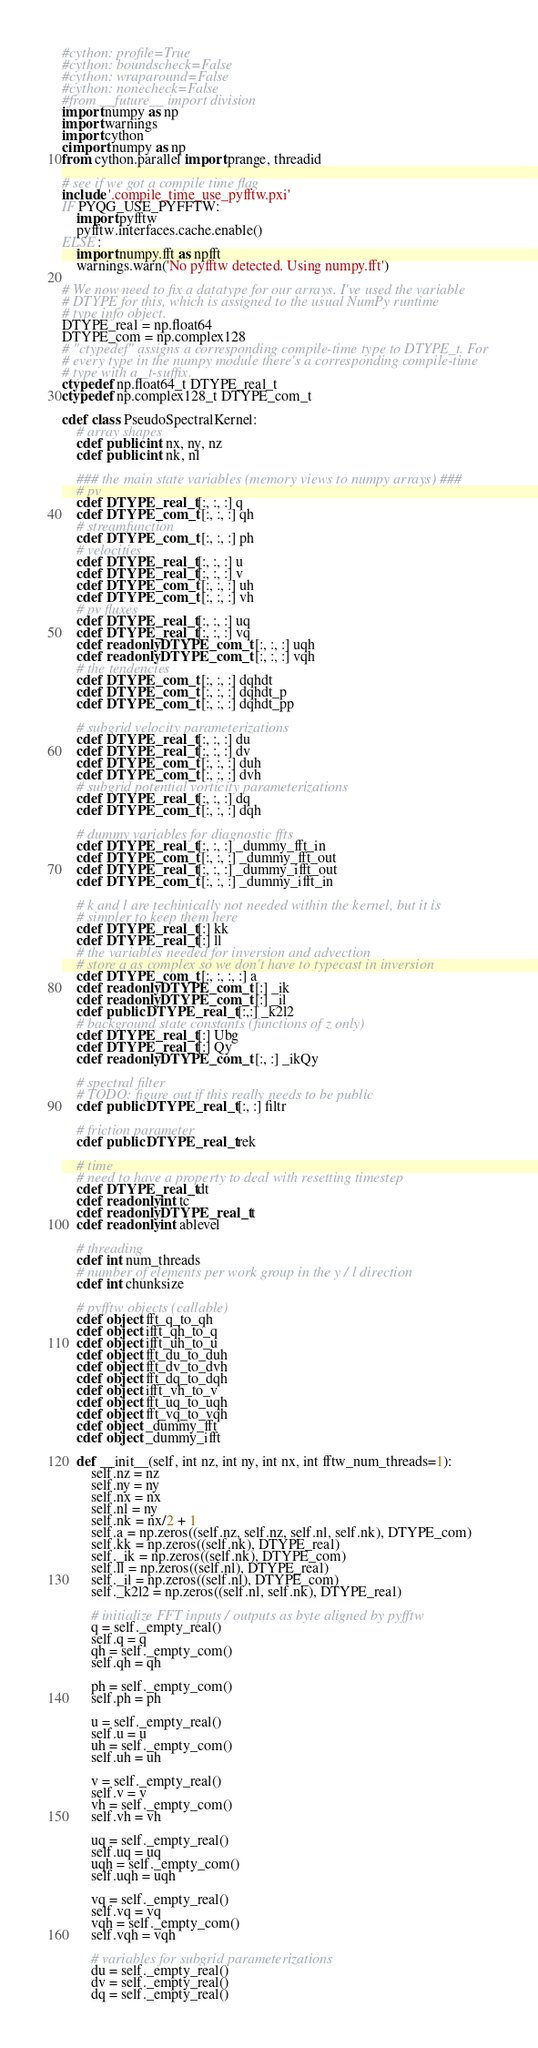<code> <loc_0><loc_0><loc_500><loc_500><_Cython_>#cython: profile=True
#cython: boundscheck=False
#cython: wraparound=False
#cython: nonecheck=False
#from __future__ import division
import numpy as np
import warnings
import cython
cimport numpy as np
from cython.parallel import prange, threadid

# see if we got a compile time flag
include '.compile_time_use_pyfftw.pxi'
IF PYQG_USE_PYFFTW:
    import pyfftw
    pyfftw.interfaces.cache.enable()
ELSE:
    import numpy.fft as npfft
    warnings.warn('No pyfftw detected. Using numpy.fft')

# We now need to fix a datatype for our arrays. I've used the variable
# DTYPE for this, which is assigned to the usual NumPy runtime
# type info object.
DTYPE_real = np.float64
DTYPE_com = np.complex128
# "ctypedef" assigns a corresponding compile-time type to DTYPE_t. For
# every type in the numpy module there's a corresponding compile-time
# type with a _t-suffix.
ctypedef np.float64_t DTYPE_real_t
ctypedef np.complex128_t DTYPE_com_t

cdef class PseudoSpectralKernel:
    # array shapes
    cdef public int nx, ny, nz
    cdef public int nk, nl

    ### the main state variables (memory views to numpy arrays) ###
    # pv
    cdef DTYPE_real_t [:, :, :] q
    cdef DTYPE_com_t [:, :, :] qh
    # streamfunction
    cdef DTYPE_com_t [:, :, :] ph
    # velocities
    cdef DTYPE_real_t [:, :, :] u
    cdef DTYPE_real_t [:, :, :] v
    cdef DTYPE_com_t [:, :, :] uh
    cdef DTYPE_com_t [:, :, :] vh
    # pv fluxes
    cdef DTYPE_real_t [:, :, :] uq
    cdef DTYPE_real_t [:, :, :] vq
    cdef readonly DTYPE_com_t [:, :, :] uqh
    cdef readonly DTYPE_com_t [:, :, :] vqh
    # the tendencies
    cdef DTYPE_com_t [:, :, :] dqhdt
    cdef DTYPE_com_t [:, :, :] dqhdt_p
    cdef DTYPE_com_t [:, :, :] dqhdt_pp

    # subgrid velocity parameterizations
    cdef DTYPE_real_t [:, :, :] du
    cdef DTYPE_real_t [:, :, :] dv
    cdef DTYPE_com_t [:, :, :] duh
    cdef DTYPE_com_t [:, :, :] dvh
    # subgrid potential vorticity parameterizations
    cdef DTYPE_real_t [:, :, :] dq
    cdef DTYPE_com_t [:, :, :] dqh

    # dummy variables for diagnostic ffts
    cdef DTYPE_real_t [:, :, :] _dummy_fft_in
    cdef DTYPE_com_t [:, :, :] _dummy_fft_out
    cdef DTYPE_real_t [:, :, :] _dummy_ifft_out
    cdef DTYPE_com_t [:, :, :] _dummy_ifft_in

    # k and l are techinically not needed within the kernel, but it is
    # simpler to keep them here
    cdef DTYPE_real_t [:] kk
    cdef DTYPE_real_t [:] ll
    # the variables needed for inversion and advection
    # store a as complex so we don't have to typecast in inversion
    cdef DTYPE_com_t [:, :, :, :] a
    cdef readonly DTYPE_com_t [:] _ik
    cdef readonly DTYPE_com_t [:] _il
    cdef public DTYPE_real_t [:,:] _k2l2
    # background state constants (functions of z only)
    cdef DTYPE_real_t [:] Ubg
    cdef DTYPE_real_t [:] Qy
    cdef readonly DTYPE_com_t [:, :] _ikQy

    # spectral filter
    # TODO: figure out if this really needs to be public
    cdef public DTYPE_real_t [:, :] filtr

    # friction parameter
    cdef public DTYPE_real_t rek

    # time
    # need to have a property to deal with resetting timestep
    cdef DTYPE_real_t dt
    cdef readonly int tc
    cdef readonly DTYPE_real_t t
    cdef readonly int ablevel

    # threading
    cdef int num_threads
    # number of elements per work group in the y / l direction
    cdef int chunksize

    # pyfftw objects (callable)
    cdef object fft_q_to_qh
    cdef object ifft_qh_to_q
    cdef object ifft_uh_to_u
    cdef object fft_du_to_duh
    cdef object fft_dv_to_dvh
    cdef object fft_dq_to_dqh
    cdef object ifft_vh_to_v
    cdef object fft_uq_to_uqh
    cdef object fft_vq_to_vqh
    cdef object _dummy_fft
    cdef object _dummy_ifft

    def __init__(self, int nz, int ny, int nx, int fftw_num_threads=1):
        self.nz = nz
        self.ny = ny
        self.nx = nx
        self.nl = ny
        self.nk = nx/2 + 1
        self.a = np.zeros((self.nz, self.nz, self.nl, self.nk), DTYPE_com)
        self.kk = np.zeros((self.nk), DTYPE_real)
        self._ik = np.zeros((self.nk), DTYPE_com)
        self.ll = np.zeros((self.nl), DTYPE_real)
        self._il = np.zeros((self.nl), DTYPE_com)
        self._k2l2 = np.zeros((self.nl, self.nk), DTYPE_real)

        # initialize FFT inputs / outputs as byte aligned by pyfftw
        q = self._empty_real()
        self.q = q
        qh = self._empty_com()
        self.qh = qh

        ph = self._empty_com()
        self.ph = ph

        u = self._empty_real()
        self.u = u
        uh = self._empty_com()
        self.uh = uh

        v = self._empty_real()
        self.v = v
        vh = self._empty_com()
        self.vh = vh

        uq = self._empty_real()
        self.uq = uq
        uqh = self._empty_com()
        self.uqh = uqh

        vq = self._empty_real()
        self.vq = vq
        vqh = self._empty_com()
        self.vqh = vqh

        # variables for subgrid parameterizations
        du = self._empty_real()
        dv = self._empty_real()
        dq = self._empty_real()</code> 